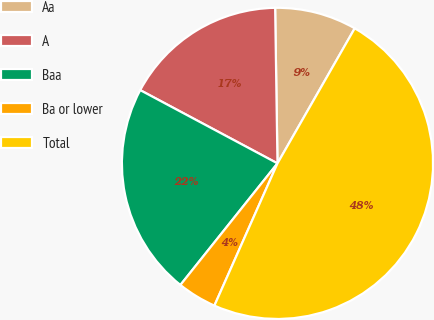<chart> <loc_0><loc_0><loc_500><loc_500><pie_chart><fcel>Aa<fcel>A<fcel>Baa<fcel>Ba or lower<fcel>Total<nl><fcel>8.51%<fcel>16.96%<fcel>22.08%<fcel>4.08%<fcel>48.38%<nl></chart> 